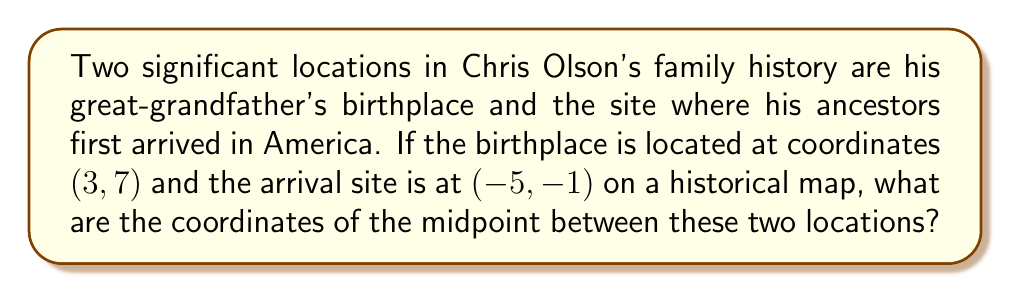Teach me how to tackle this problem. To find the midpoint between two points, we use the midpoint formula:

$$ \text{Midpoint} = \left(\frac{x_1 + x_2}{2}, \frac{y_1 + y_2}{2}\right) $$

Where $(x_1, y_1)$ is the first point and $(x_2, y_2)$ is the second point.

Given:
- Great-grandfather's birthplace: $(x_1, y_1) = (3, 7)$
- Ancestors' arrival site: $(x_2, y_2) = (-5, -1)$

Step 1: Calculate the x-coordinate of the midpoint
$$ x_{\text{midpoint}} = \frac{x_1 + x_2}{2} = \frac{3 + (-5)}{2} = \frac{-2}{2} = -1 $$

Step 2: Calculate the y-coordinate of the midpoint
$$ y_{\text{midpoint}} = \frac{y_1 + y_2}{2} = \frac{7 + (-1)}{2} = \frac{6}{2} = 3 $$

Therefore, the midpoint coordinates are $(-1, 3)$.

To visualize this:

[asy]
unitsize(1cm);
grid(-6,-2,4,8,gray(0.7));
dot((3,7),red);
dot((-5,-1),red);
dot((-1,3),blue);
label("(3,7)",(3,7),NE,red);
label("(-5,-1)",(-5,-1),SW,red);
label("(-1,3)",(-1,3),SE,blue);
draw((3,7)--(-5,-1),dashed);
[/asy]
Answer: The coordinates of the midpoint are $(-1, 3)$. 